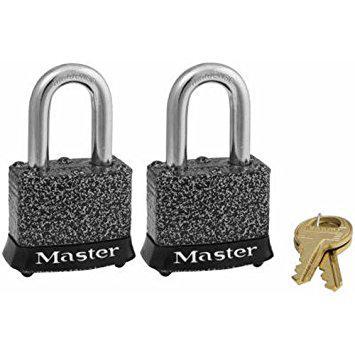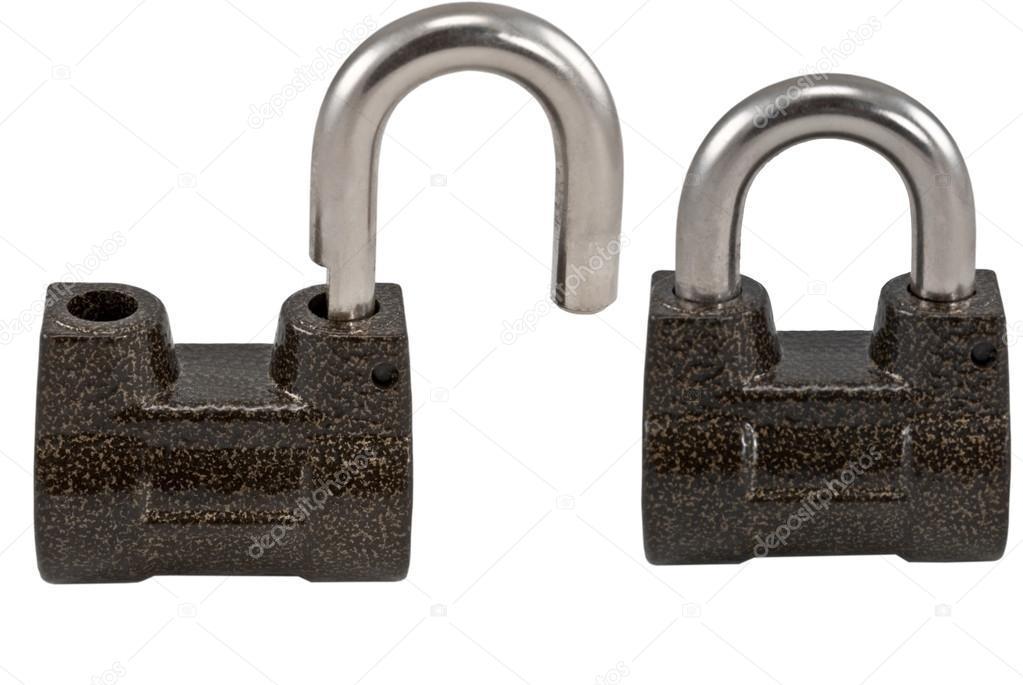The first image is the image on the left, the second image is the image on the right. Evaluate the accuracy of this statement regarding the images: "There are four padlocks, all of which are closed.". Is it true? Answer yes or no. No. The first image is the image on the left, the second image is the image on the right. Considering the images on both sides, is "Multiple keys are next to a pair of the same type locks in one image." valid? Answer yes or no. Yes. 